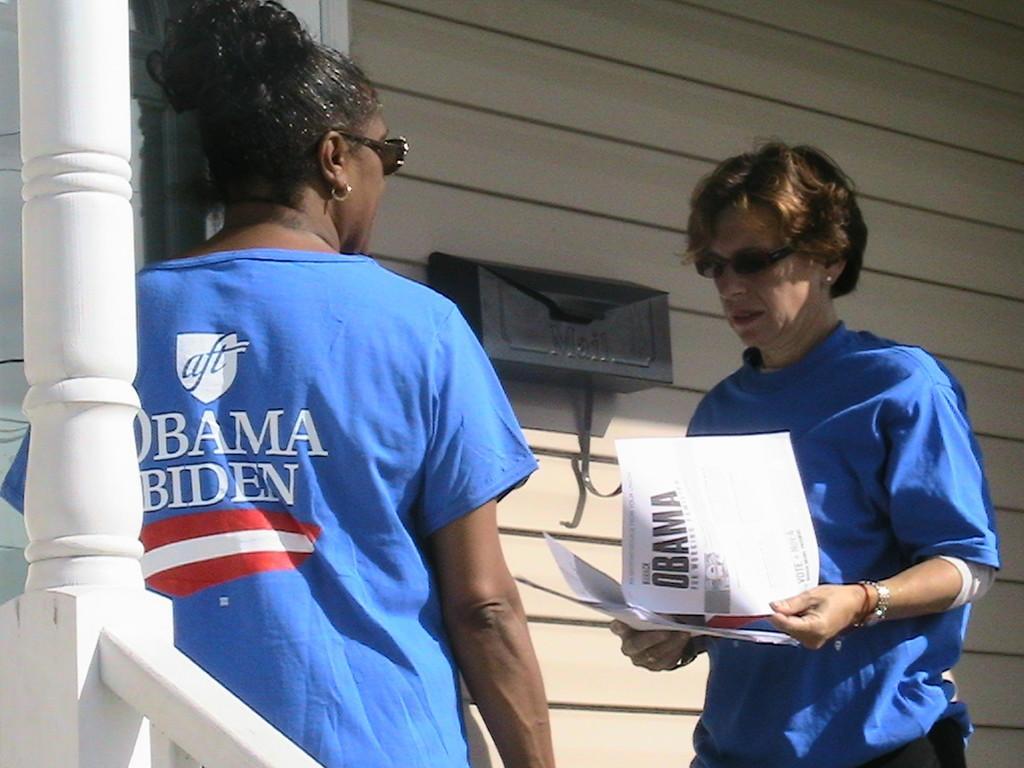Can you describe this image briefly? In this picture we can see two people and one person is holding papers and in the background we can see an object on the wall. 